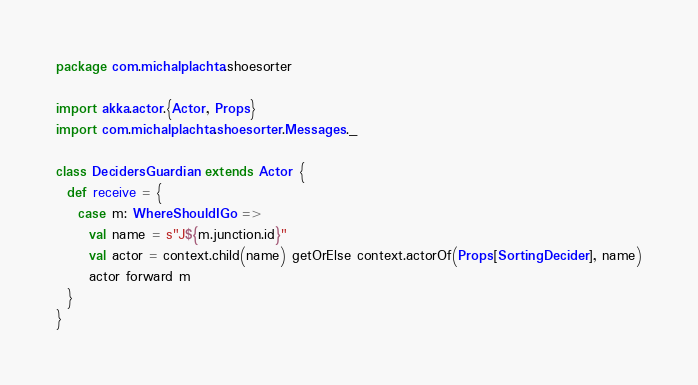<code> <loc_0><loc_0><loc_500><loc_500><_Scala_>package com.michalplachta.shoesorter

import akka.actor.{Actor, Props}
import com.michalplachta.shoesorter.Messages._

class DecidersGuardian extends Actor {
  def receive = {
    case m: WhereShouldIGo =>
      val name = s"J${m.junction.id}"
      val actor = context.child(name) getOrElse context.actorOf(Props[SortingDecider], name)
      actor forward m
  }
}
</code> 